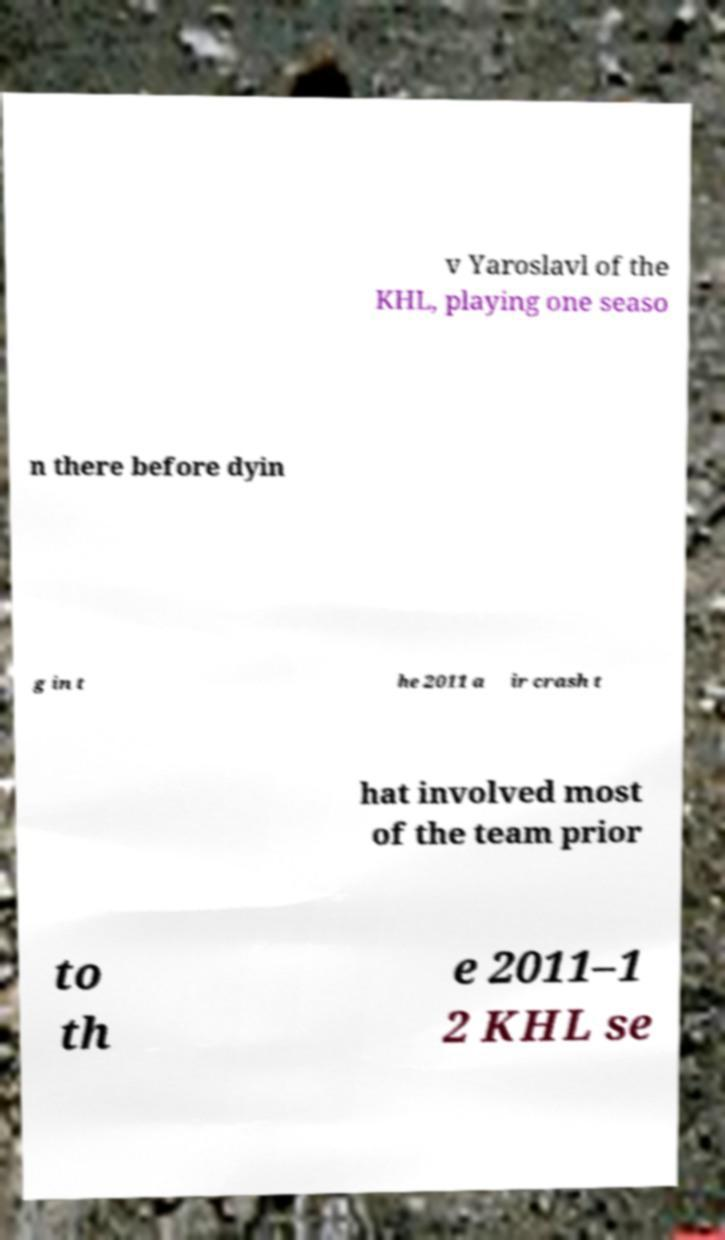Could you extract and type out the text from this image? v Yaroslavl of the KHL, playing one seaso n there before dyin g in t he 2011 a ir crash t hat involved most of the team prior to th e 2011–1 2 KHL se 